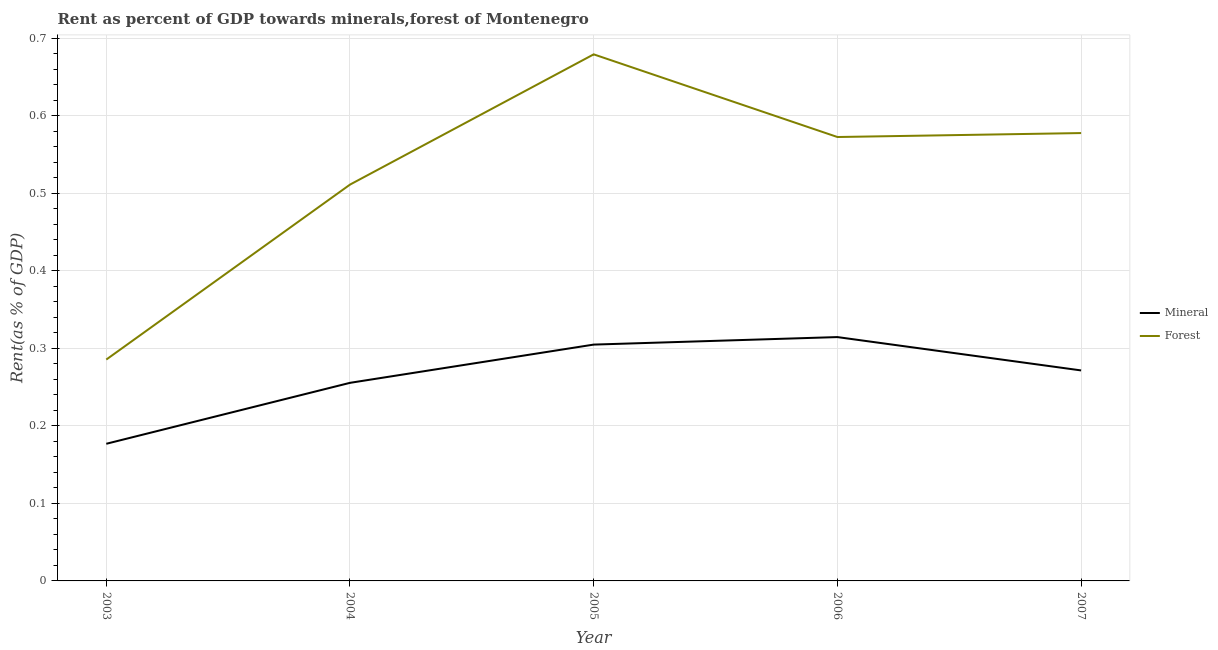How many different coloured lines are there?
Offer a very short reply. 2. Does the line corresponding to mineral rent intersect with the line corresponding to forest rent?
Provide a succinct answer. No. What is the forest rent in 2005?
Keep it short and to the point. 0.68. Across all years, what is the maximum mineral rent?
Provide a succinct answer. 0.31. Across all years, what is the minimum mineral rent?
Keep it short and to the point. 0.18. In which year was the mineral rent maximum?
Offer a terse response. 2006. What is the total forest rent in the graph?
Make the answer very short. 2.63. What is the difference between the forest rent in 2004 and that in 2005?
Provide a short and direct response. -0.17. What is the difference between the forest rent in 2006 and the mineral rent in 2003?
Your response must be concise. 0.4. What is the average forest rent per year?
Provide a succinct answer. 0.53. In the year 2003, what is the difference between the mineral rent and forest rent?
Give a very brief answer. -0.11. In how many years, is the forest rent greater than 0.30000000000000004 %?
Your response must be concise. 4. What is the ratio of the mineral rent in 2004 to that in 2006?
Give a very brief answer. 0.81. Is the forest rent in 2006 less than that in 2007?
Ensure brevity in your answer.  Yes. Is the difference between the mineral rent in 2005 and 2006 greater than the difference between the forest rent in 2005 and 2006?
Your response must be concise. No. What is the difference between the highest and the second highest forest rent?
Make the answer very short. 0.1. What is the difference between the highest and the lowest mineral rent?
Your answer should be very brief. 0.14. In how many years, is the mineral rent greater than the average mineral rent taken over all years?
Provide a succinct answer. 3. Is the sum of the mineral rent in 2004 and 2006 greater than the maximum forest rent across all years?
Make the answer very short. No. Is the mineral rent strictly greater than the forest rent over the years?
Give a very brief answer. No. Is the forest rent strictly less than the mineral rent over the years?
Offer a very short reply. No. How many lines are there?
Offer a terse response. 2. How many years are there in the graph?
Make the answer very short. 5. What is the difference between two consecutive major ticks on the Y-axis?
Keep it short and to the point. 0.1. Does the graph contain grids?
Provide a succinct answer. Yes. Where does the legend appear in the graph?
Ensure brevity in your answer.  Center right. How many legend labels are there?
Offer a very short reply. 2. How are the legend labels stacked?
Your answer should be compact. Vertical. What is the title of the graph?
Your answer should be compact. Rent as percent of GDP towards minerals,forest of Montenegro. What is the label or title of the Y-axis?
Keep it short and to the point. Rent(as % of GDP). What is the Rent(as % of GDP) in Mineral in 2003?
Your response must be concise. 0.18. What is the Rent(as % of GDP) of Forest in 2003?
Provide a succinct answer. 0.29. What is the Rent(as % of GDP) of Mineral in 2004?
Your answer should be compact. 0.26. What is the Rent(as % of GDP) in Forest in 2004?
Your response must be concise. 0.51. What is the Rent(as % of GDP) in Mineral in 2005?
Give a very brief answer. 0.3. What is the Rent(as % of GDP) of Forest in 2005?
Offer a terse response. 0.68. What is the Rent(as % of GDP) in Mineral in 2006?
Provide a short and direct response. 0.31. What is the Rent(as % of GDP) of Forest in 2006?
Your answer should be very brief. 0.57. What is the Rent(as % of GDP) of Mineral in 2007?
Provide a succinct answer. 0.27. What is the Rent(as % of GDP) in Forest in 2007?
Offer a very short reply. 0.58. Across all years, what is the maximum Rent(as % of GDP) of Mineral?
Offer a terse response. 0.31. Across all years, what is the maximum Rent(as % of GDP) of Forest?
Keep it short and to the point. 0.68. Across all years, what is the minimum Rent(as % of GDP) in Mineral?
Your answer should be compact. 0.18. Across all years, what is the minimum Rent(as % of GDP) of Forest?
Offer a terse response. 0.29. What is the total Rent(as % of GDP) in Mineral in the graph?
Provide a succinct answer. 1.32. What is the total Rent(as % of GDP) in Forest in the graph?
Keep it short and to the point. 2.63. What is the difference between the Rent(as % of GDP) of Mineral in 2003 and that in 2004?
Provide a short and direct response. -0.08. What is the difference between the Rent(as % of GDP) of Forest in 2003 and that in 2004?
Your answer should be very brief. -0.23. What is the difference between the Rent(as % of GDP) in Mineral in 2003 and that in 2005?
Your response must be concise. -0.13. What is the difference between the Rent(as % of GDP) of Forest in 2003 and that in 2005?
Give a very brief answer. -0.39. What is the difference between the Rent(as % of GDP) of Mineral in 2003 and that in 2006?
Offer a very short reply. -0.14. What is the difference between the Rent(as % of GDP) in Forest in 2003 and that in 2006?
Your response must be concise. -0.29. What is the difference between the Rent(as % of GDP) of Mineral in 2003 and that in 2007?
Your response must be concise. -0.09. What is the difference between the Rent(as % of GDP) in Forest in 2003 and that in 2007?
Offer a terse response. -0.29. What is the difference between the Rent(as % of GDP) in Mineral in 2004 and that in 2005?
Your answer should be very brief. -0.05. What is the difference between the Rent(as % of GDP) in Forest in 2004 and that in 2005?
Your response must be concise. -0.17. What is the difference between the Rent(as % of GDP) in Mineral in 2004 and that in 2006?
Keep it short and to the point. -0.06. What is the difference between the Rent(as % of GDP) of Forest in 2004 and that in 2006?
Provide a succinct answer. -0.06. What is the difference between the Rent(as % of GDP) of Mineral in 2004 and that in 2007?
Make the answer very short. -0.02. What is the difference between the Rent(as % of GDP) of Forest in 2004 and that in 2007?
Your answer should be very brief. -0.07. What is the difference between the Rent(as % of GDP) of Mineral in 2005 and that in 2006?
Offer a terse response. -0.01. What is the difference between the Rent(as % of GDP) of Forest in 2005 and that in 2006?
Offer a very short reply. 0.11. What is the difference between the Rent(as % of GDP) in Mineral in 2005 and that in 2007?
Offer a very short reply. 0.03. What is the difference between the Rent(as % of GDP) of Forest in 2005 and that in 2007?
Offer a terse response. 0.1. What is the difference between the Rent(as % of GDP) of Mineral in 2006 and that in 2007?
Your answer should be very brief. 0.04. What is the difference between the Rent(as % of GDP) in Forest in 2006 and that in 2007?
Offer a terse response. -0.01. What is the difference between the Rent(as % of GDP) of Mineral in 2003 and the Rent(as % of GDP) of Forest in 2004?
Ensure brevity in your answer.  -0.33. What is the difference between the Rent(as % of GDP) in Mineral in 2003 and the Rent(as % of GDP) in Forest in 2005?
Give a very brief answer. -0.5. What is the difference between the Rent(as % of GDP) of Mineral in 2003 and the Rent(as % of GDP) of Forest in 2006?
Ensure brevity in your answer.  -0.4. What is the difference between the Rent(as % of GDP) in Mineral in 2003 and the Rent(as % of GDP) in Forest in 2007?
Offer a terse response. -0.4. What is the difference between the Rent(as % of GDP) of Mineral in 2004 and the Rent(as % of GDP) of Forest in 2005?
Your response must be concise. -0.42. What is the difference between the Rent(as % of GDP) in Mineral in 2004 and the Rent(as % of GDP) in Forest in 2006?
Offer a terse response. -0.32. What is the difference between the Rent(as % of GDP) in Mineral in 2004 and the Rent(as % of GDP) in Forest in 2007?
Make the answer very short. -0.32. What is the difference between the Rent(as % of GDP) of Mineral in 2005 and the Rent(as % of GDP) of Forest in 2006?
Your answer should be very brief. -0.27. What is the difference between the Rent(as % of GDP) in Mineral in 2005 and the Rent(as % of GDP) in Forest in 2007?
Offer a terse response. -0.27. What is the difference between the Rent(as % of GDP) in Mineral in 2006 and the Rent(as % of GDP) in Forest in 2007?
Ensure brevity in your answer.  -0.26. What is the average Rent(as % of GDP) in Mineral per year?
Make the answer very short. 0.26. What is the average Rent(as % of GDP) of Forest per year?
Make the answer very short. 0.53. In the year 2003, what is the difference between the Rent(as % of GDP) in Mineral and Rent(as % of GDP) in Forest?
Make the answer very short. -0.11. In the year 2004, what is the difference between the Rent(as % of GDP) in Mineral and Rent(as % of GDP) in Forest?
Your answer should be very brief. -0.26. In the year 2005, what is the difference between the Rent(as % of GDP) of Mineral and Rent(as % of GDP) of Forest?
Make the answer very short. -0.37. In the year 2006, what is the difference between the Rent(as % of GDP) of Mineral and Rent(as % of GDP) of Forest?
Provide a succinct answer. -0.26. In the year 2007, what is the difference between the Rent(as % of GDP) of Mineral and Rent(as % of GDP) of Forest?
Provide a short and direct response. -0.31. What is the ratio of the Rent(as % of GDP) in Mineral in 2003 to that in 2004?
Your response must be concise. 0.69. What is the ratio of the Rent(as % of GDP) in Forest in 2003 to that in 2004?
Your answer should be compact. 0.56. What is the ratio of the Rent(as % of GDP) in Mineral in 2003 to that in 2005?
Your answer should be very brief. 0.58. What is the ratio of the Rent(as % of GDP) in Forest in 2003 to that in 2005?
Provide a succinct answer. 0.42. What is the ratio of the Rent(as % of GDP) of Mineral in 2003 to that in 2006?
Your answer should be compact. 0.56. What is the ratio of the Rent(as % of GDP) in Forest in 2003 to that in 2006?
Your answer should be very brief. 0.5. What is the ratio of the Rent(as % of GDP) in Mineral in 2003 to that in 2007?
Make the answer very short. 0.65. What is the ratio of the Rent(as % of GDP) of Forest in 2003 to that in 2007?
Make the answer very short. 0.49. What is the ratio of the Rent(as % of GDP) of Mineral in 2004 to that in 2005?
Your answer should be very brief. 0.84. What is the ratio of the Rent(as % of GDP) of Forest in 2004 to that in 2005?
Offer a terse response. 0.75. What is the ratio of the Rent(as % of GDP) in Mineral in 2004 to that in 2006?
Your answer should be compact. 0.81. What is the ratio of the Rent(as % of GDP) of Forest in 2004 to that in 2006?
Your answer should be very brief. 0.89. What is the ratio of the Rent(as % of GDP) in Mineral in 2004 to that in 2007?
Your answer should be very brief. 0.94. What is the ratio of the Rent(as % of GDP) in Forest in 2004 to that in 2007?
Give a very brief answer. 0.88. What is the ratio of the Rent(as % of GDP) in Mineral in 2005 to that in 2006?
Your answer should be very brief. 0.97. What is the ratio of the Rent(as % of GDP) of Forest in 2005 to that in 2006?
Ensure brevity in your answer.  1.19. What is the ratio of the Rent(as % of GDP) in Mineral in 2005 to that in 2007?
Give a very brief answer. 1.12. What is the ratio of the Rent(as % of GDP) in Forest in 2005 to that in 2007?
Your answer should be very brief. 1.18. What is the ratio of the Rent(as % of GDP) in Mineral in 2006 to that in 2007?
Your response must be concise. 1.16. What is the ratio of the Rent(as % of GDP) in Forest in 2006 to that in 2007?
Offer a very short reply. 0.99. What is the difference between the highest and the second highest Rent(as % of GDP) of Mineral?
Provide a short and direct response. 0.01. What is the difference between the highest and the second highest Rent(as % of GDP) in Forest?
Make the answer very short. 0.1. What is the difference between the highest and the lowest Rent(as % of GDP) in Mineral?
Make the answer very short. 0.14. What is the difference between the highest and the lowest Rent(as % of GDP) of Forest?
Give a very brief answer. 0.39. 